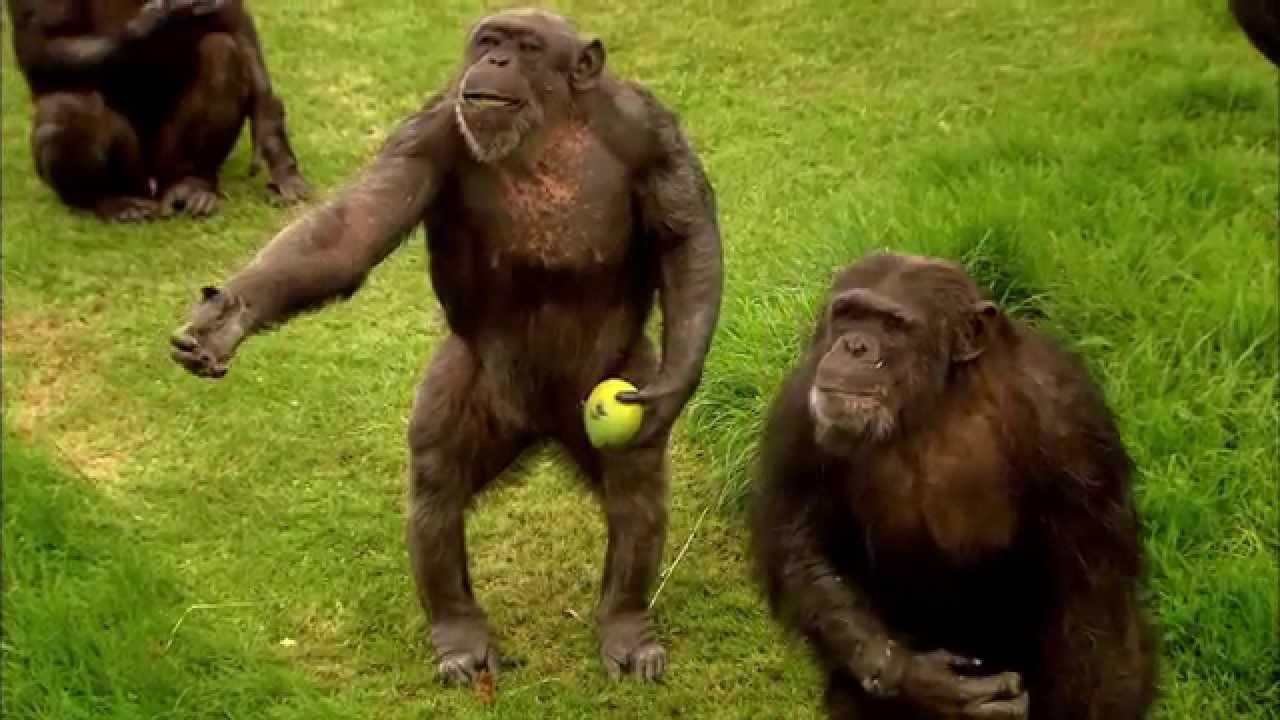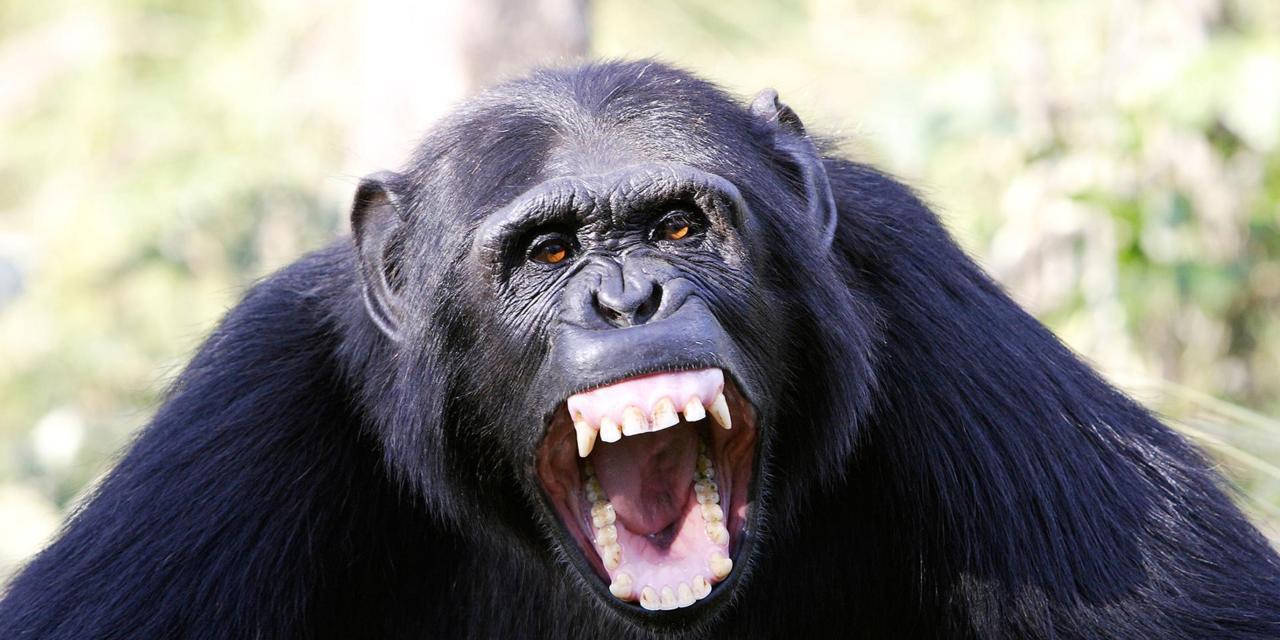The first image is the image on the left, the second image is the image on the right. Considering the images on both sides, is "The left image contains more chimps than the right image." valid? Answer yes or no. Yes. 